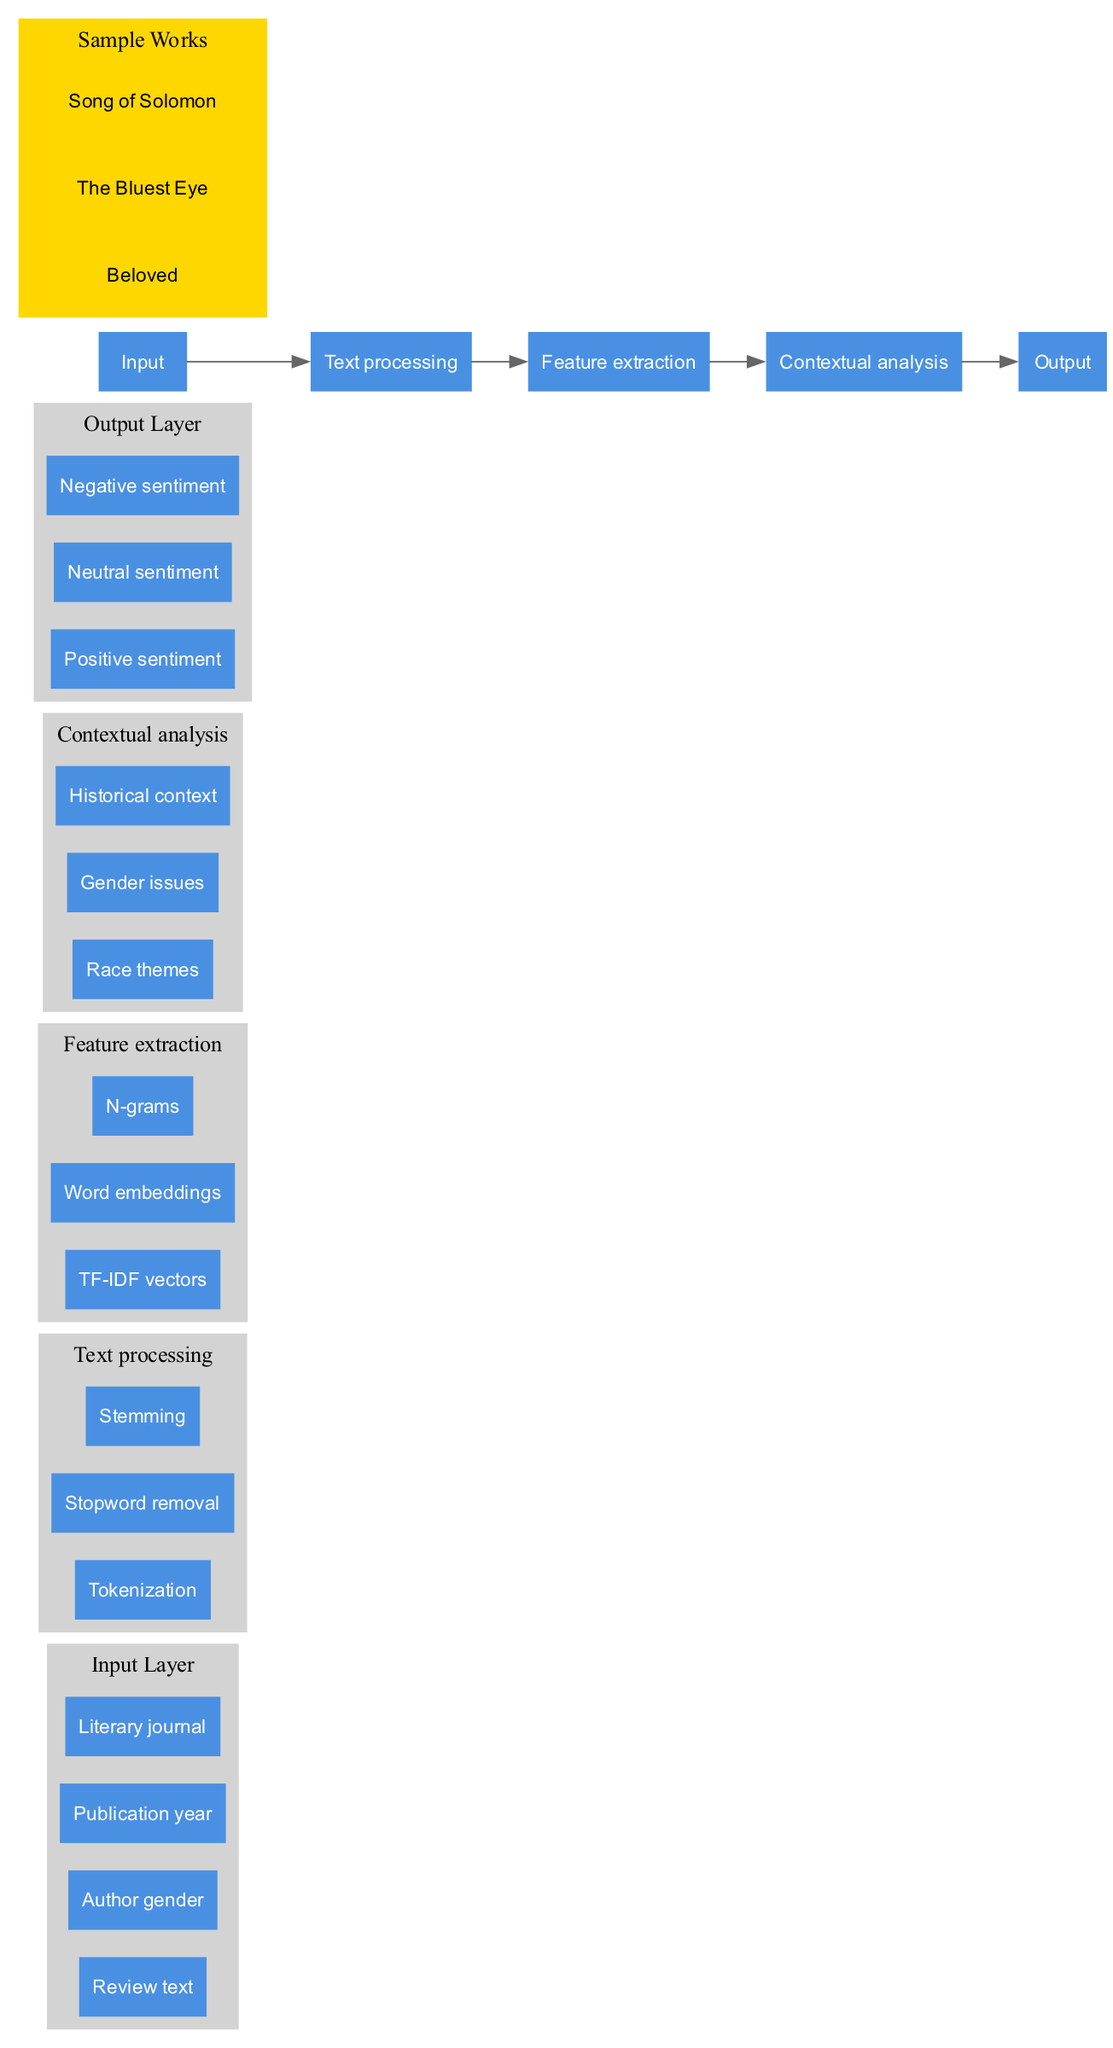What are the nodes in the input layer? The input layer consists of four nodes: "Review text", "Author gender", "Publication year", and "Literary journal". These represent the features used for sentiment analysis.
Answer: Review text, Author gender, Publication year, Literary journal How many hidden layers are there? The diagram depicts three hidden layers: "Text processing", "Feature extraction", and "Contextual analysis", indicating the various stages of processing the input data.
Answer: 3 What is the last node in the output layer? The output layer has three nodes: "Positive sentiment", "Neutral sentiment", and "Negative sentiment", with "Negative sentiment" being the last one listed.
Answer: Negative sentiment What processing occurs in the hidden layer labeled "Feature extraction"? The "Feature extraction" layer includes three nodes: "TF-IDF vectors", "Word embeddings", and "N-grams", indicating the methods for extracting relevant features from the text.
Answer: TF-IDF vectors, Word embeddings, N-grams What connects the "Contextual analysis" layer to the output layer? The "Contextual analysis" layer is connected to the output layer, which suggests that the analysis of race themes, gender issues, and historical context directly informs the final sentiment classification.
Answer: Output Which hidden layer is responsible for text processing? The layer titled "Text processing" is responsible for processing the review text, specifically through tokenization, stopword removal, and stemming.
Answer: Text processing What is the first step in the network when processing the input? The first processing step is "Text processing", where the input data undergoes tokenization, stopword removal, and stemming before moving on to feature extraction.
Answer: Text processing How many nodes are in the "Contextual analysis" layer? The "Contextual analysis" layer contains three nodes: "Race themes", "Gender issues", and "Historical context", representing the various contextual factors considered in the analysis.
Answer: 3 What are the sample works included in the diagram? The sample works listed in the diagram are "Beloved", "The Bluest Eye", and "Song of Solomon", which serve as examples for the analysis being executed.
Answer: Beloved, The Bluest Eye, Song of Solomon 